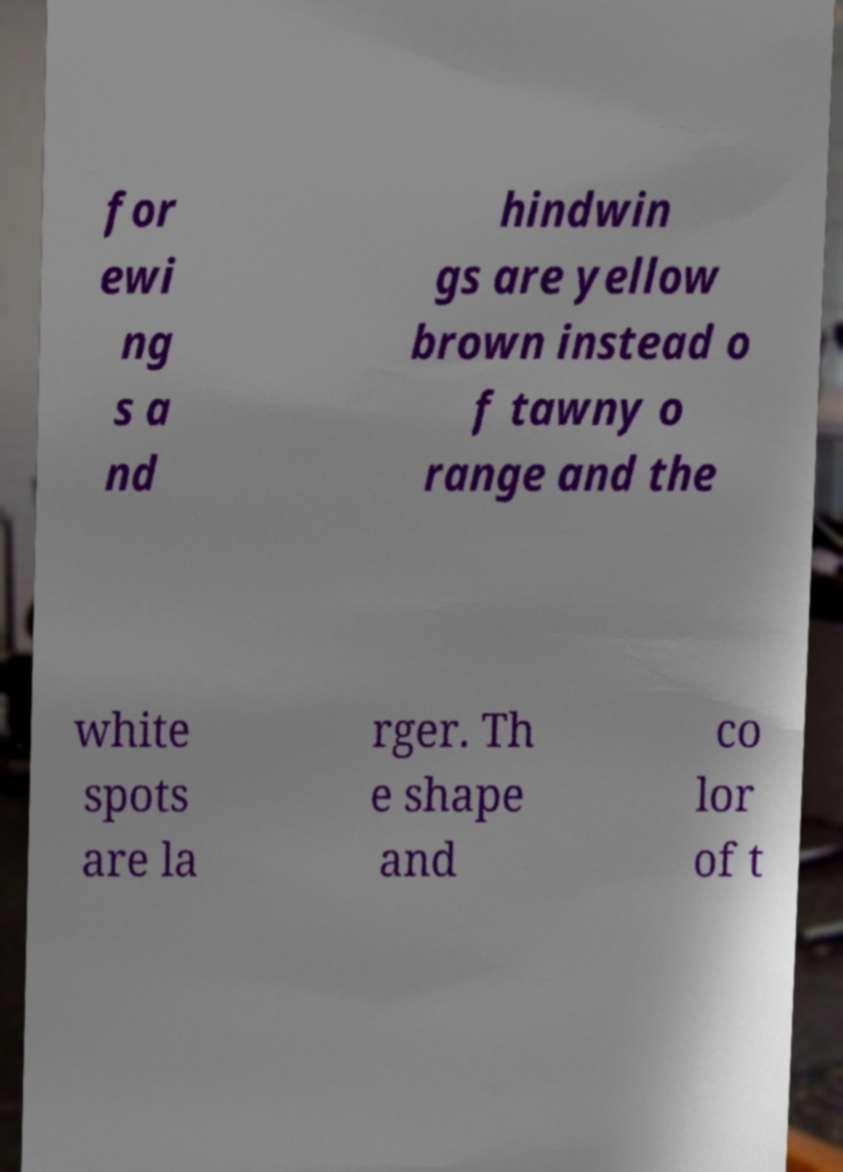Can you accurately transcribe the text from the provided image for me? for ewi ng s a nd hindwin gs are yellow brown instead o f tawny o range and the white spots are la rger. Th e shape and co lor of t 